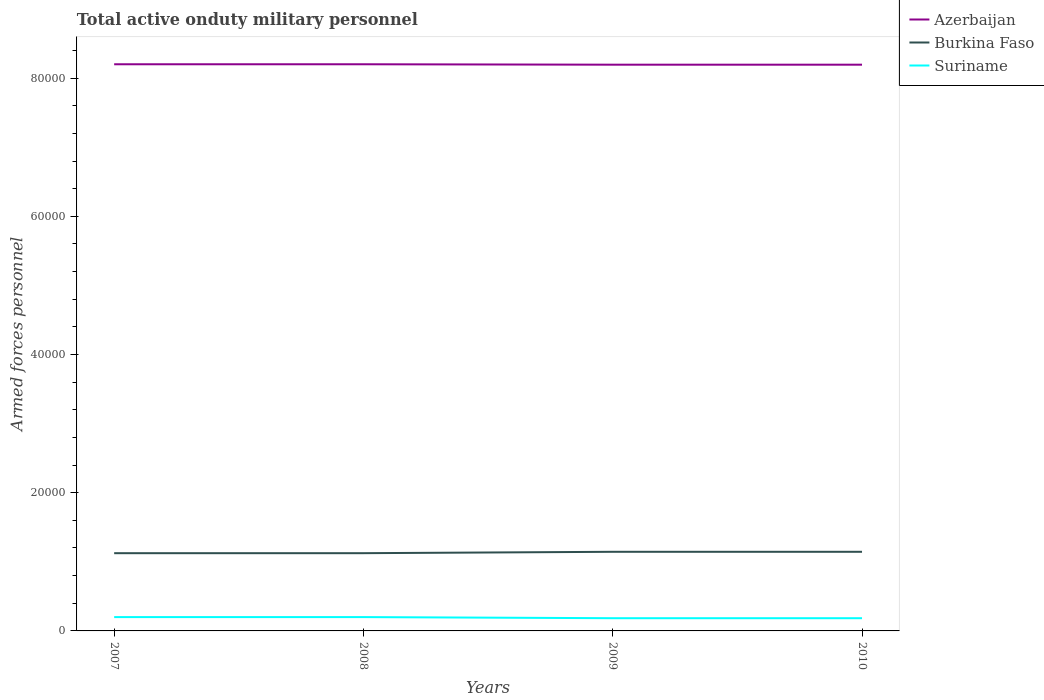How many different coloured lines are there?
Provide a succinct answer. 3. Across all years, what is the maximum number of armed forces personnel in Suriname?
Provide a short and direct response. 1840. In which year was the number of armed forces personnel in Azerbaijan maximum?
Keep it short and to the point. 2009. What is the total number of armed forces personnel in Suriname in the graph?
Give a very brief answer. 160. What is the difference between the highest and the second highest number of armed forces personnel in Azerbaijan?
Offer a very short reply. 60. Is the number of armed forces personnel in Burkina Faso strictly greater than the number of armed forces personnel in Suriname over the years?
Your answer should be compact. No. How many lines are there?
Keep it short and to the point. 3. How many years are there in the graph?
Ensure brevity in your answer.  4. What is the difference between two consecutive major ticks on the Y-axis?
Your answer should be compact. 2.00e+04. Where does the legend appear in the graph?
Offer a very short reply. Top right. What is the title of the graph?
Your answer should be very brief. Total active onduty military personnel. Does "Djibouti" appear as one of the legend labels in the graph?
Keep it short and to the point. No. What is the label or title of the X-axis?
Your answer should be very brief. Years. What is the label or title of the Y-axis?
Provide a short and direct response. Armed forces personnel. What is the Armed forces personnel in Azerbaijan in 2007?
Your response must be concise. 8.20e+04. What is the Armed forces personnel of Burkina Faso in 2007?
Make the answer very short. 1.12e+04. What is the Armed forces personnel of Suriname in 2007?
Keep it short and to the point. 2000. What is the Armed forces personnel in Azerbaijan in 2008?
Ensure brevity in your answer.  8.20e+04. What is the Armed forces personnel of Burkina Faso in 2008?
Offer a terse response. 1.12e+04. What is the Armed forces personnel of Suriname in 2008?
Give a very brief answer. 2000. What is the Armed forces personnel of Azerbaijan in 2009?
Your response must be concise. 8.19e+04. What is the Armed forces personnel in Burkina Faso in 2009?
Provide a short and direct response. 1.14e+04. What is the Armed forces personnel in Suriname in 2009?
Your answer should be compact. 1840. What is the Armed forces personnel of Azerbaijan in 2010?
Your answer should be compact. 8.19e+04. What is the Armed forces personnel of Burkina Faso in 2010?
Your answer should be very brief. 1.14e+04. What is the Armed forces personnel of Suriname in 2010?
Your answer should be compact. 1840. Across all years, what is the maximum Armed forces personnel of Azerbaijan?
Your response must be concise. 8.20e+04. Across all years, what is the maximum Armed forces personnel of Burkina Faso?
Give a very brief answer. 1.14e+04. Across all years, what is the maximum Armed forces personnel in Suriname?
Provide a succinct answer. 2000. Across all years, what is the minimum Armed forces personnel of Azerbaijan?
Give a very brief answer. 8.19e+04. Across all years, what is the minimum Armed forces personnel in Burkina Faso?
Give a very brief answer. 1.12e+04. Across all years, what is the minimum Armed forces personnel of Suriname?
Provide a succinct answer. 1840. What is the total Armed forces personnel of Azerbaijan in the graph?
Your answer should be very brief. 3.28e+05. What is the total Armed forces personnel in Burkina Faso in the graph?
Your answer should be very brief. 4.54e+04. What is the total Armed forces personnel in Suriname in the graph?
Offer a very short reply. 7680. What is the difference between the Armed forces personnel of Azerbaijan in 2007 and that in 2008?
Offer a terse response. 0. What is the difference between the Armed forces personnel in Burkina Faso in 2007 and that in 2009?
Provide a short and direct response. -200. What is the difference between the Armed forces personnel in Suriname in 2007 and that in 2009?
Offer a terse response. 160. What is the difference between the Armed forces personnel in Burkina Faso in 2007 and that in 2010?
Give a very brief answer. -200. What is the difference between the Armed forces personnel in Suriname in 2007 and that in 2010?
Offer a very short reply. 160. What is the difference between the Armed forces personnel in Azerbaijan in 2008 and that in 2009?
Your answer should be very brief. 60. What is the difference between the Armed forces personnel of Burkina Faso in 2008 and that in 2009?
Your answer should be very brief. -200. What is the difference between the Armed forces personnel in Suriname in 2008 and that in 2009?
Ensure brevity in your answer.  160. What is the difference between the Armed forces personnel of Burkina Faso in 2008 and that in 2010?
Give a very brief answer. -200. What is the difference between the Armed forces personnel of Suriname in 2008 and that in 2010?
Your response must be concise. 160. What is the difference between the Armed forces personnel of Azerbaijan in 2007 and the Armed forces personnel of Burkina Faso in 2008?
Give a very brief answer. 7.08e+04. What is the difference between the Armed forces personnel in Azerbaijan in 2007 and the Armed forces personnel in Suriname in 2008?
Offer a terse response. 8.00e+04. What is the difference between the Armed forces personnel in Burkina Faso in 2007 and the Armed forces personnel in Suriname in 2008?
Your answer should be compact. 9250. What is the difference between the Armed forces personnel of Azerbaijan in 2007 and the Armed forces personnel of Burkina Faso in 2009?
Give a very brief answer. 7.06e+04. What is the difference between the Armed forces personnel in Azerbaijan in 2007 and the Armed forces personnel in Suriname in 2009?
Give a very brief answer. 8.02e+04. What is the difference between the Armed forces personnel in Burkina Faso in 2007 and the Armed forces personnel in Suriname in 2009?
Your response must be concise. 9410. What is the difference between the Armed forces personnel of Azerbaijan in 2007 and the Armed forces personnel of Burkina Faso in 2010?
Ensure brevity in your answer.  7.06e+04. What is the difference between the Armed forces personnel of Azerbaijan in 2007 and the Armed forces personnel of Suriname in 2010?
Provide a succinct answer. 8.02e+04. What is the difference between the Armed forces personnel of Burkina Faso in 2007 and the Armed forces personnel of Suriname in 2010?
Give a very brief answer. 9410. What is the difference between the Armed forces personnel of Azerbaijan in 2008 and the Armed forces personnel of Burkina Faso in 2009?
Ensure brevity in your answer.  7.06e+04. What is the difference between the Armed forces personnel of Azerbaijan in 2008 and the Armed forces personnel of Suriname in 2009?
Your answer should be very brief. 8.02e+04. What is the difference between the Armed forces personnel of Burkina Faso in 2008 and the Armed forces personnel of Suriname in 2009?
Provide a succinct answer. 9410. What is the difference between the Armed forces personnel of Azerbaijan in 2008 and the Armed forces personnel of Burkina Faso in 2010?
Give a very brief answer. 7.06e+04. What is the difference between the Armed forces personnel in Azerbaijan in 2008 and the Armed forces personnel in Suriname in 2010?
Keep it short and to the point. 8.02e+04. What is the difference between the Armed forces personnel of Burkina Faso in 2008 and the Armed forces personnel of Suriname in 2010?
Your answer should be very brief. 9410. What is the difference between the Armed forces personnel in Azerbaijan in 2009 and the Armed forces personnel in Burkina Faso in 2010?
Give a very brief answer. 7.05e+04. What is the difference between the Armed forces personnel of Azerbaijan in 2009 and the Armed forces personnel of Suriname in 2010?
Provide a short and direct response. 8.01e+04. What is the difference between the Armed forces personnel of Burkina Faso in 2009 and the Armed forces personnel of Suriname in 2010?
Make the answer very short. 9610. What is the average Armed forces personnel in Azerbaijan per year?
Make the answer very short. 8.20e+04. What is the average Armed forces personnel of Burkina Faso per year?
Make the answer very short. 1.14e+04. What is the average Armed forces personnel of Suriname per year?
Your answer should be very brief. 1920. In the year 2007, what is the difference between the Armed forces personnel in Azerbaijan and Armed forces personnel in Burkina Faso?
Keep it short and to the point. 7.08e+04. In the year 2007, what is the difference between the Armed forces personnel in Azerbaijan and Armed forces personnel in Suriname?
Ensure brevity in your answer.  8.00e+04. In the year 2007, what is the difference between the Armed forces personnel in Burkina Faso and Armed forces personnel in Suriname?
Your answer should be very brief. 9250. In the year 2008, what is the difference between the Armed forces personnel in Azerbaijan and Armed forces personnel in Burkina Faso?
Keep it short and to the point. 7.08e+04. In the year 2008, what is the difference between the Armed forces personnel of Azerbaijan and Armed forces personnel of Suriname?
Provide a succinct answer. 8.00e+04. In the year 2008, what is the difference between the Armed forces personnel of Burkina Faso and Armed forces personnel of Suriname?
Ensure brevity in your answer.  9250. In the year 2009, what is the difference between the Armed forces personnel in Azerbaijan and Armed forces personnel in Burkina Faso?
Give a very brief answer. 7.05e+04. In the year 2009, what is the difference between the Armed forces personnel of Azerbaijan and Armed forces personnel of Suriname?
Make the answer very short. 8.01e+04. In the year 2009, what is the difference between the Armed forces personnel in Burkina Faso and Armed forces personnel in Suriname?
Give a very brief answer. 9610. In the year 2010, what is the difference between the Armed forces personnel in Azerbaijan and Armed forces personnel in Burkina Faso?
Give a very brief answer. 7.05e+04. In the year 2010, what is the difference between the Armed forces personnel in Azerbaijan and Armed forces personnel in Suriname?
Your answer should be very brief. 8.01e+04. In the year 2010, what is the difference between the Armed forces personnel in Burkina Faso and Armed forces personnel in Suriname?
Keep it short and to the point. 9610. What is the ratio of the Armed forces personnel of Azerbaijan in 2007 to that in 2008?
Make the answer very short. 1. What is the ratio of the Armed forces personnel of Burkina Faso in 2007 to that in 2008?
Provide a succinct answer. 1. What is the ratio of the Armed forces personnel in Suriname in 2007 to that in 2008?
Keep it short and to the point. 1. What is the ratio of the Armed forces personnel in Azerbaijan in 2007 to that in 2009?
Give a very brief answer. 1. What is the ratio of the Armed forces personnel in Burkina Faso in 2007 to that in 2009?
Make the answer very short. 0.98. What is the ratio of the Armed forces personnel of Suriname in 2007 to that in 2009?
Provide a short and direct response. 1.09. What is the ratio of the Armed forces personnel of Azerbaijan in 2007 to that in 2010?
Offer a very short reply. 1. What is the ratio of the Armed forces personnel in Burkina Faso in 2007 to that in 2010?
Your answer should be very brief. 0.98. What is the ratio of the Armed forces personnel in Suriname in 2007 to that in 2010?
Your response must be concise. 1.09. What is the ratio of the Armed forces personnel of Azerbaijan in 2008 to that in 2009?
Ensure brevity in your answer.  1. What is the ratio of the Armed forces personnel of Burkina Faso in 2008 to that in 2009?
Your answer should be compact. 0.98. What is the ratio of the Armed forces personnel of Suriname in 2008 to that in 2009?
Provide a short and direct response. 1.09. What is the ratio of the Armed forces personnel in Azerbaijan in 2008 to that in 2010?
Provide a succinct answer. 1. What is the ratio of the Armed forces personnel of Burkina Faso in 2008 to that in 2010?
Make the answer very short. 0.98. What is the ratio of the Armed forces personnel of Suriname in 2008 to that in 2010?
Offer a very short reply. 1.09. What is the ratio of the Armed forces personnel of Burkina Faso in 2009 to that in 2010?
Make the answer very short. 1. What is the difference between the highest and the second highest Armed forces personnel in Azerbaijan?
Your response must be concise. 0. What is the difference between the highest and the second highest Armed forces personnel in Suriname?
Your answer should be very brief. 0. What is the difference between the highest and the lowest Armed forces personnel in Burkina Faso?
Give a very brief answer. 200. What is the difference between the highest and the lowest Armed forces personnel of Suriname?
Your answer should be compact. 160. 